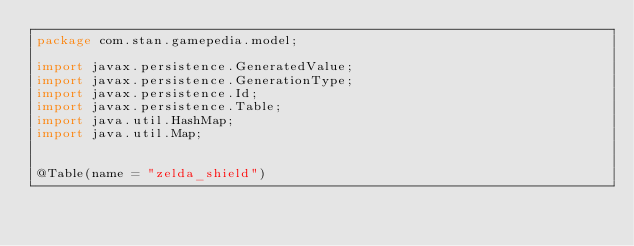<code> <loc_0><loc_0><loc_500><loc_500><_Java_>package com.stan.gamepedia.model;

import javax.persistence.GeneratedValue;
import javax.persistence.GenerationType;
import javax.persistence.Id;
import javax.persistence.Table;
import java.util.HashMap;
import java.util.Map;


@Table(name = "zelda_shield")</code> 